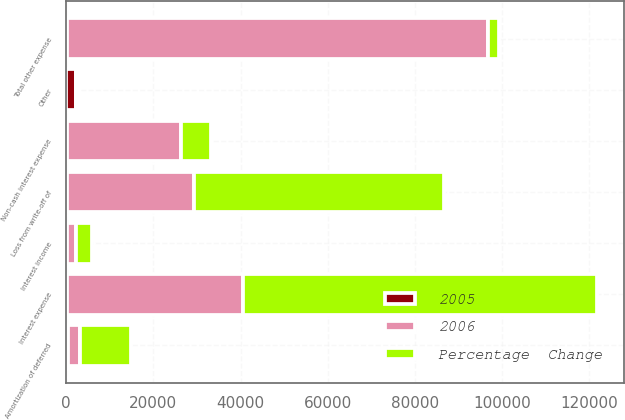Convert chart. <chart><loc_0><loc_0><loc_500><loc_500><stacked_bar_chart><ecel><fcel>Interest income<fcel>Interest expense<fcel>Non-cash interest expense<fcel>Amortization of deferred<fcel>Loss from write-off of<fcel>Other<fcel>Total other expense<nl><fcel>Percentage  Change<fcel>3814<fcel>81283<fcel>6845<fcel>11584<fcel>57233<fcel>692<fcel>2491.15<nl><fcel>2006<fcel>2096<fcel>40511<fcel>26234<fcel>2850<fcel>29271<fcel>31<fcel>96739<nl><fcel>2005<fcel>82<fcel>100.6<fcel>73.9<fcel>306.5<fcel>95.5<fcel>2132.3<fcel>57.6<nl></chart> 